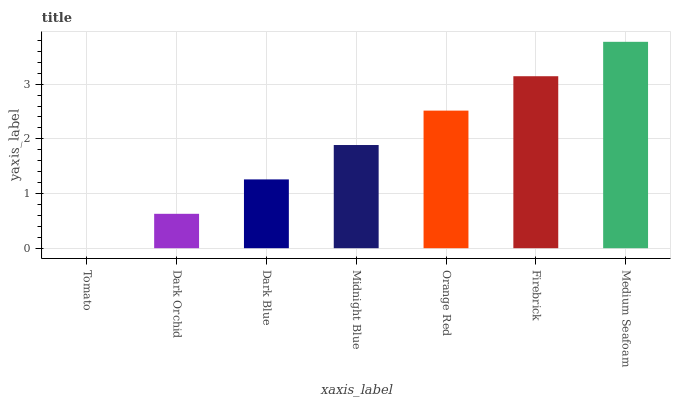Is Tomato the minimum?
Answer yes or no. Yes. Is Medium Seafoam the maximum?
Answer yes or no. Yes. Is Dark Orchid the minimum?
Answer yes or no. No. Is Dark Orchid the maximum?
Answer yes or no. No. Is Dark Orchid greater than Tomato?
Answer yes or no. Yes. Is Tomato less than Dark Orchid?
Answer yes or no. Yes. Is Tomato greater than Dark Orchid?
Answer yes or no. No. Is Dark Orchid less than Tomato?
Answer yes or no. No. Is Midnight Blue the high median?
Answer yes or no. Yes. Is Midnight Blue the low median?
Answer yes or no. Yes. Is Firebrick the high median?
Answer yes or no. No. Is Dark Blue the low median?
Answer yes or no. No. 